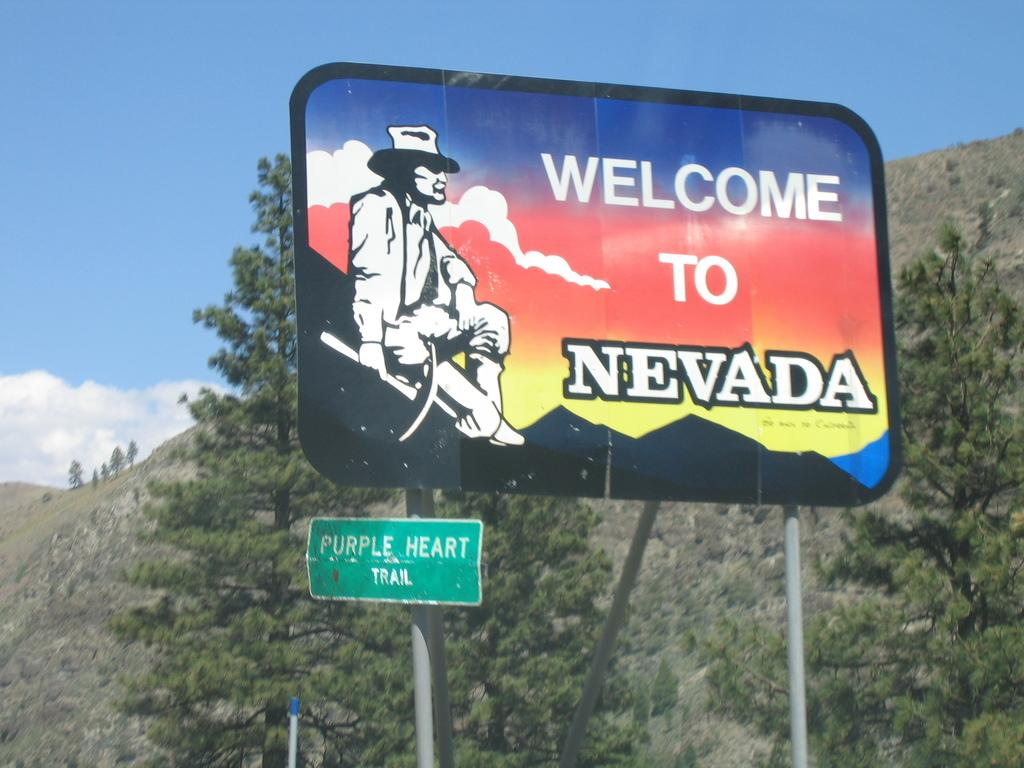<image>
Share a concise interpretation of the image provided. A large billboard in the woods says Welcome To Nevada. 